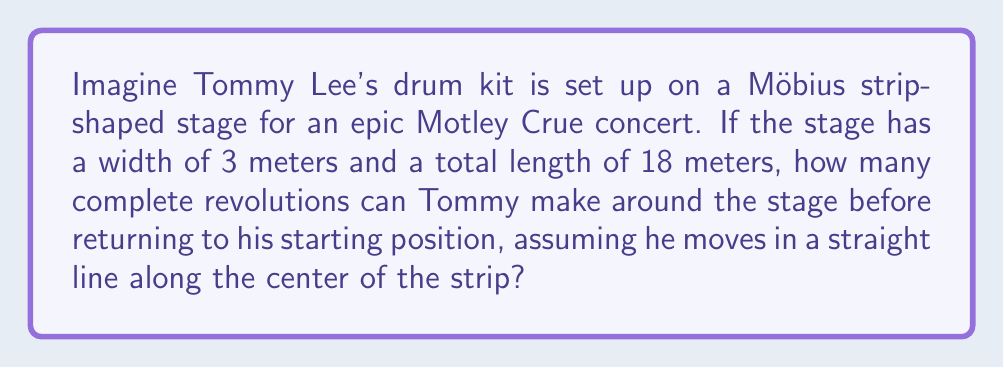Teach me how to tackle this problem. Let's approach this step-by-step, keeping in mind the unique properties of a Möbius strip:

1) First, we need to understand that a Möbius strip has only one side and one edge. When you traverse the entire length of the strip, you end up on the opposite side of where you started.

2) The total length of the stage is 18 meters. In a normal circular stage, Tommy would complete one revolution after 18 meters. However, this is a Möbius strip.

3) To calculate the number of revolutions, we need to determine how far Tommy needs to travel to return to his exact starting position (same side of the strip).

4) On a Möbius strip, after one complete trip around (18 meters), Tommy will be on the opposite side of the strip from where he started.

5) To return to the same side, Tommy needs to go around twice. This can be represented mathematically as:

   $$\text{Distance to return to start} = 2 \times \text{Total length of strip}$$
   $$\text{Distance to return to start} = 2 \times 18 = 36 \text{ meters}$$

6) Now, to calculate the number of revolutions, we divide this distance by the original length of the strip:

   $$\text{Number of revolutions} = \frac{\text{Distance to return to start}}{\text{Total length of strip}}$$
   $$\text{Number of revolutions} = \frac{36}{18} = 2$$

Therefore, Tommy will complete 2 revolutions before returning to his exact starting position.
Answer: 2 revolutions 